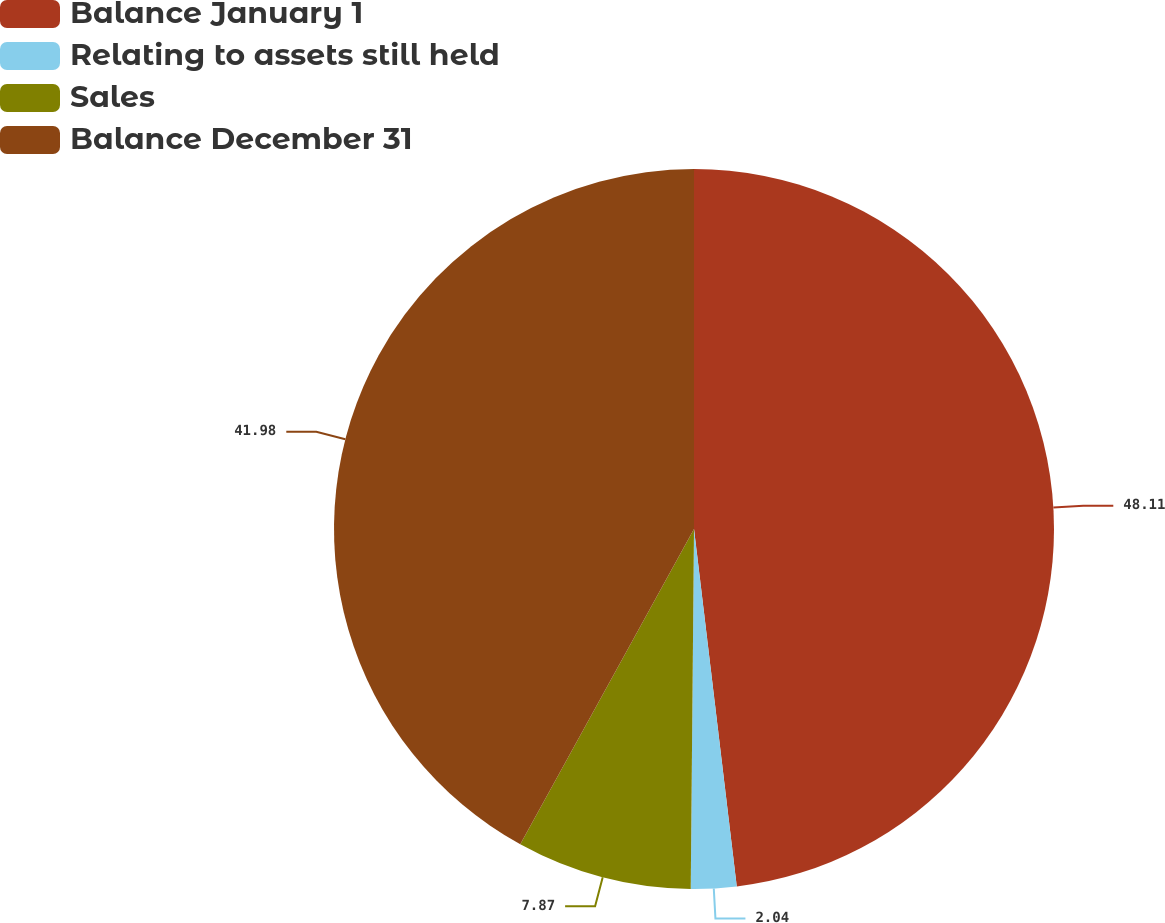Convert chart to OTSL. <chart><loc_0><loc_0><loc_500><loc_500><pie_chart><fcel>Balance January 1<fcel>Relating to assets still held<fcel>Sales<fcel>Balance December 31<nl><fcel>48.1%<fcel>2.04%<fcel>7.87%<fcel>41.98%<nl></chart> 